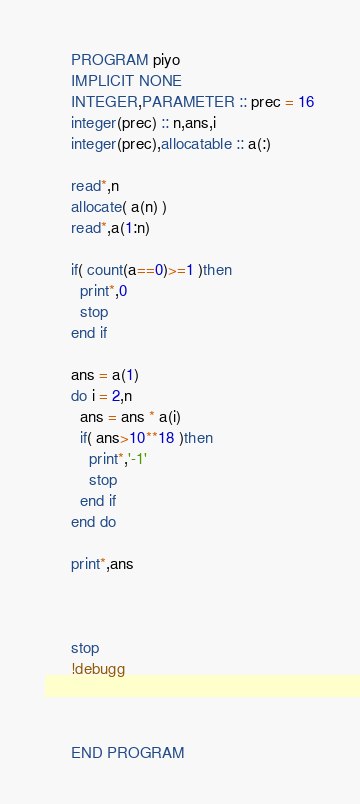Convert code to text. <code><loc_0><loc_0><loc_500><loc_500><_FORTRAN_>      PROGRAM piyo
      IMPLICIT NONE
      INTEGER,PARAMETER :: prec = 16
      integer(prec) :: n,ans,i
      integer(prec),allocatable :: a(:)
      
      read*,n
      allocate( a(n) )
      read*,a(1:n)
      
      if( count(a==0)>=1 )then
        print*,0
        stop
      end if
      
      ans = a(1)
      do i = 2,n
        ans = ans * a(i)
        if( ans>10**18 )then
          print*,'-1'
          stop
        end if
      end do
      
      print*,ans
      
      
      
      stop
      !debugg
      
      
      
      END PROGRAM</code> 